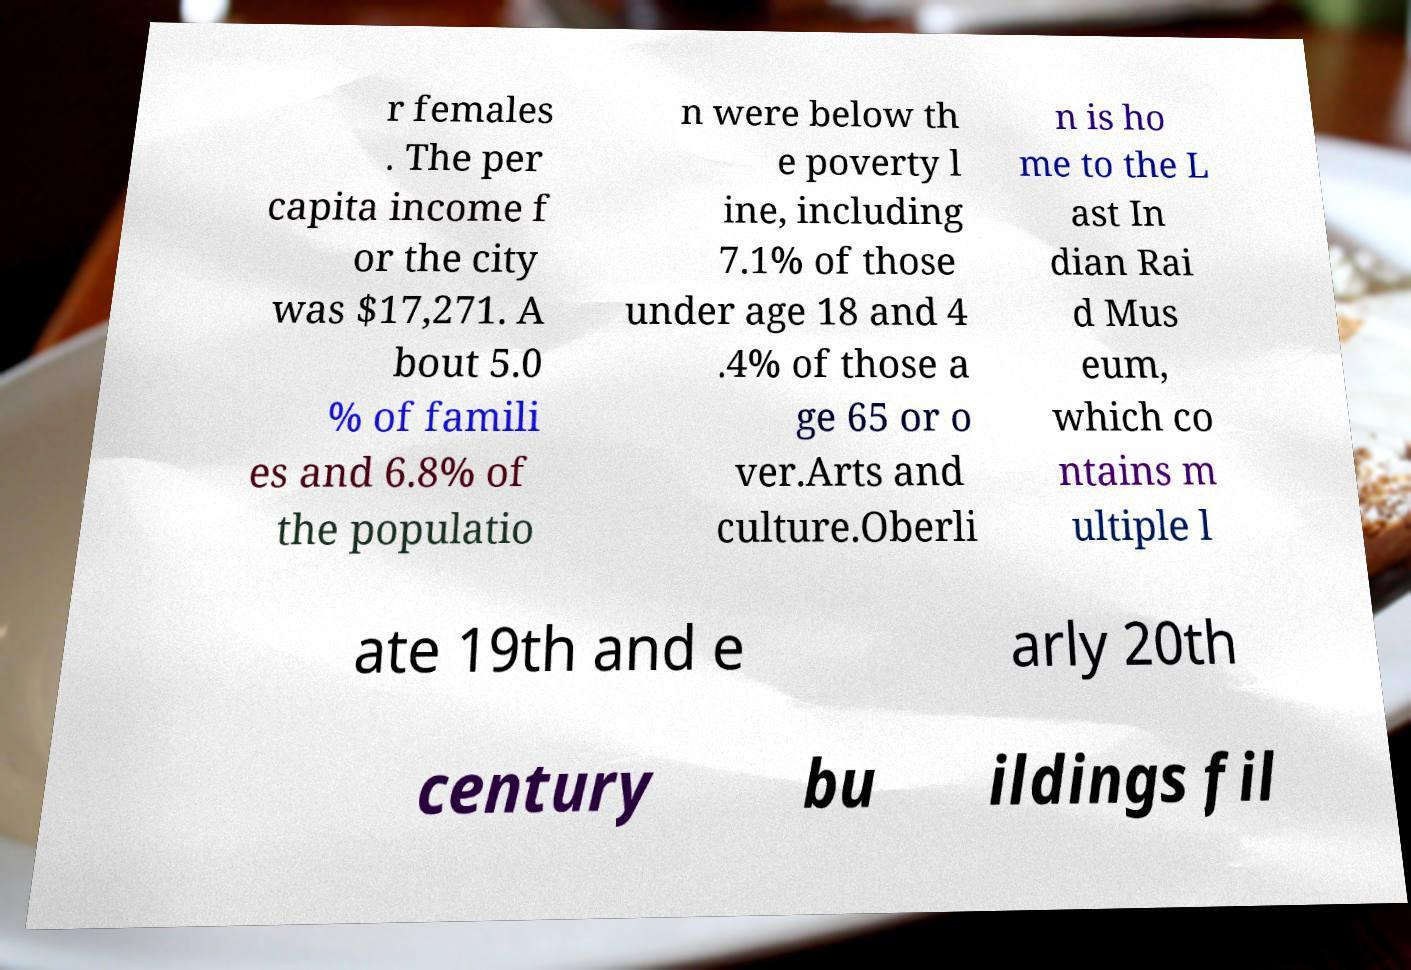Please read and relay the text visible in this image. What does it say? r females . The per capita income f or the city was $17,271. A bout 5.0 % of famili es and 6.8% of the populatio n were below th e poverty l ine, including 7.1% of those under age 18 and 4 .4% of those a ge 65 or o ver.Arts and culture.Oberli n is ho me to the L ast In dian Rai d Mus eum, which co ntains m ultiple l ate 19th and e arly 20th century bu ildings fil 